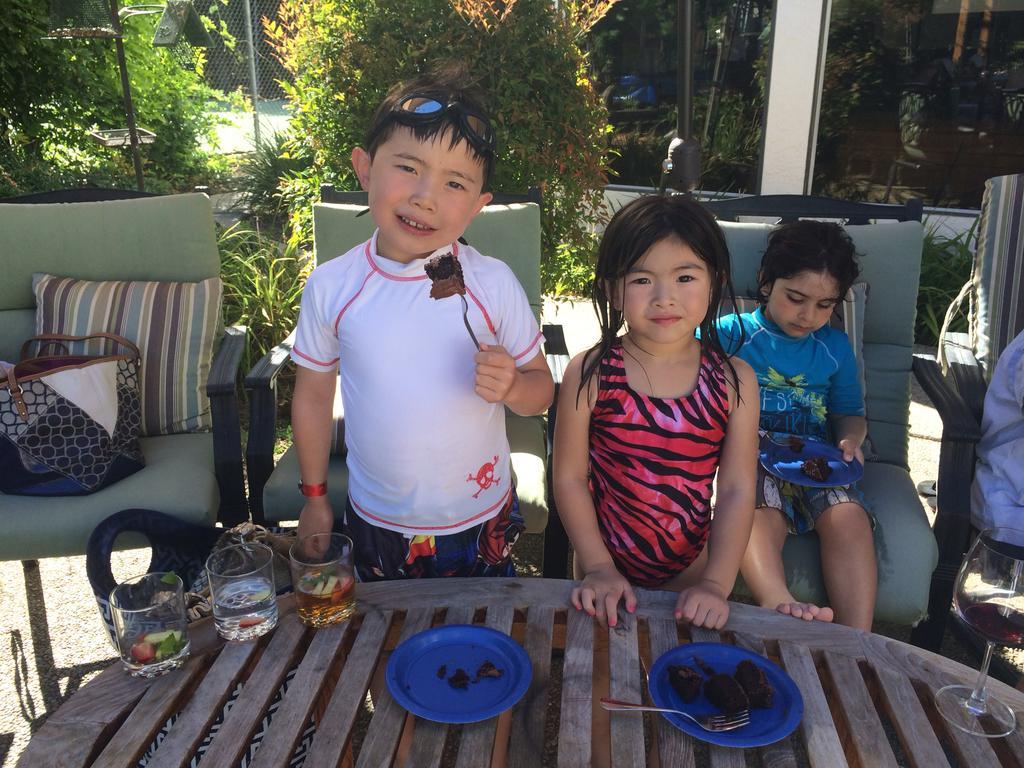Can you describe this image briefly? In this Image I see a boy and 2 girls, in which these 2 are standing and this girl is sitting on a chair. I can also see that this boy is holding a fork on which there is a cake and this girl is holding a plate on which there is cake on it. I see a table over here, on which there are glasses and a plate in which there are cakes. I can also see few chairs over here. In the background I see plants and trees. 